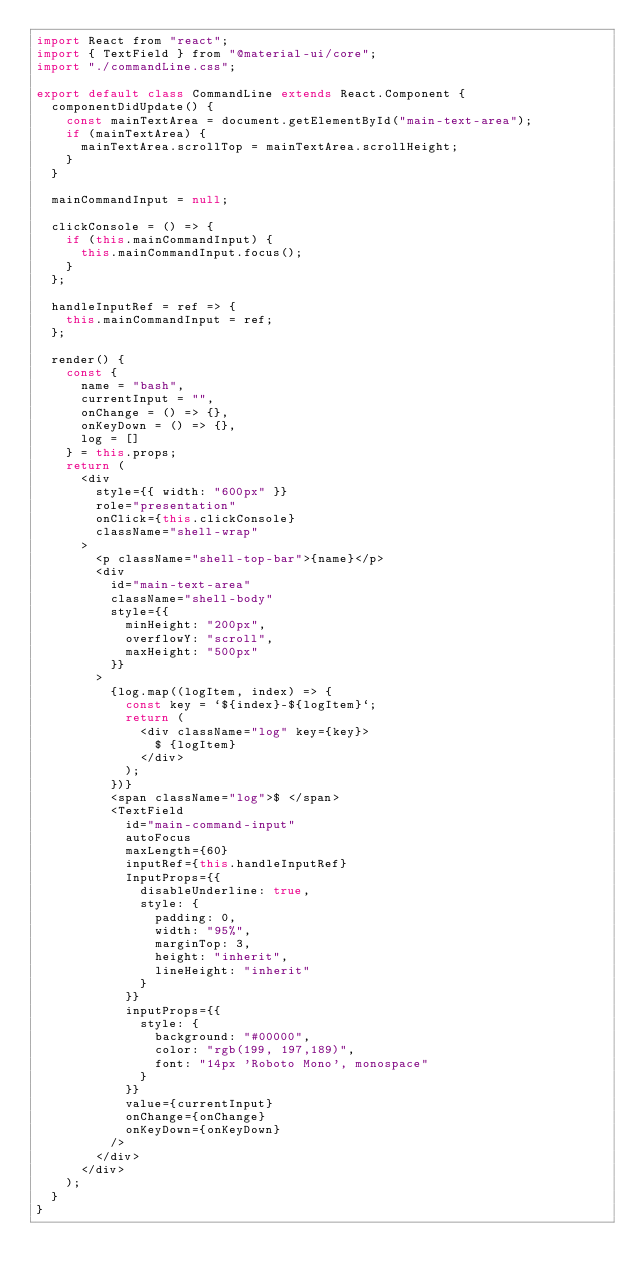<code> <loc_0><loc_0><loc_500><loc_500><_JavaScript_>import React from "react";
import { TextField } from "@material-ui/core";
import "./commandLine.css";

export default class CommandLine extends React.Component {
  componentDidUpdate() {
    const mainTextArea = document.getElementById("main-text-area");
    if (mainTextArea) {
      mainTextArea.scrollTop = mainTextArea.scrollHeight;
    }
  }

  mainCommandInput = null;

  clickConsole = () => {
    if (this.mainCommandInput) {
      this.mainCommandInput.focus();
    }
  };

  handleInputRef = ref => {
    this.mainCommandInput = ref;
  };

  render() {
    const {
      name = "bash",
      currentInput = "",
      onChange = () => {},
      onKeyDown = () => {},
      log = []
    } = this.props;
    return (
      <div
        style={{ width: "600px" }}
        role="presentation"
        onClick={this.clickConsole}
        className="shell-wrap"
      >
        <p className="shell-top-bar">{name}</p>
        <div
          id="main-text-area"
          className="shell-body"
          style={{
            minHeight: "200px",
            overflowY: "scroll",
            maxHeight: "500px"
          }}
        >
          {log.map((logItem, index) => {
            const key = `${index}-${logItem}`;
            return (
              <div className="log" key={key}>
                $ {logItem}
              </div>
            );
          })}
          <span className="log">$ </span>
          <TextField
            id="main-command-input"
            autoFocus
            maxLength={60}
            inputRef={this.handleInputRef}
            InputProps={{
              disableUnderline: true,
              style: {
                padding: 0,
                width: "95%",
                marginTop: 3,
                height: "inherit",
                lineHeight: "inherit"
              }
            }}
            inputProps={{
              style: {
                background: "#00000",
                color: "rgb(199, 197,189)",
                font: "14px 'Roboto Mono', monospace"
              }
            }}
            value={currentInput}
            onChange={onChange}
            onKeyDown={onKeyDown}
          />
        </div>
      </div>
    );
  }
}
</code> 